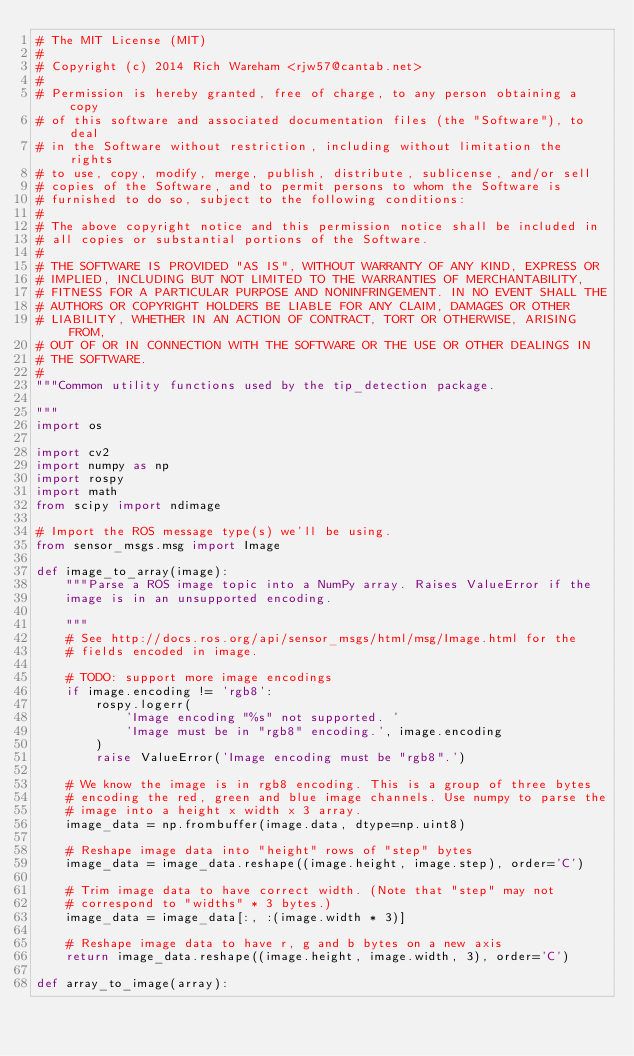Convert code to text. <code><loc_0><loc_0><loc_500><loc_500><_Python_># The MIT License (MIT)
#
# Copyright (c) 2014 Rich Wareham <rjw57@cantab.net>
#
# Permission is hereby granted, free of charge, to any person obtaining a copy
# of this software and associated documentation files (the "Software"), to deal
# in the Software without restriction, including without limitation the rights
# to use, copy, modify, merge, publish, distribute, sublicense, and/or sell
# copies of the Software, and to permit persons to whom the Software is
# furnished to do so, subject to the following conditions:
#
# The above copyright notice and this permission notice shall be included in
# all copies or substantial portions of the Software.
#
# THE SOFTWARE IS PROVIDED "AS IS", WITHOUT WARRANTY OF ANY KIND, EXPRESS OR
# IMPLIED, INCLUDING BUT NOT LIMITED TO THE WARRANTIES OF MERCHANTABILITY,
# FITNESS FOR A PARTICULAR PURPOSE AND NONINFRINGEMENT. IN NO EVENT SHALL THE
# AUTHORS OR COPYRIGHT HOLDERS BE LIABLE FOR ANY CLAIM, DAMAGES OR OTHER
# LIABILITY, WHETHER IN AN ACTION OF CONTRACT, TORT OR OTHERWISE, ARISING FROM,
# OUT OF OR IN CONNECTION WITH THE SOFTWARE OR THE USE OR OTHER DEALINGS IN
# THE SOFTWARE.
#
"""Common utility functions used by the tip_detection package.

"""
import os

import cv2
import numpy as np
import rospy
import math
from scipy import ndimage

# Import the ROS message type(s) we'll be using.
from sensor_msgs.msg import Image

def image_to_array(image):
    """Parse a ROS image topic into a NumPy array. Raises ValueError if the
    image is in an unsupported encoding.

    """
    # See http://docs.ros.org/api/sensor_msgs/html/msg/Image.html for the
    # fields encoded in image.

    # TODO: support more image encodings
    if image.encoding != 'rgb8':
        rospy.logerr(
            'Image encoding "%s" not supported. '
            'Image must be in "rgb8" encoding.', image.encoding
        )
        raise ValueError('Image encoding must be "rgb8".')

    # We know the image is in rgb8 encoding. This is a group of three bytes
    # encoding the red, green and blue image channels. Use numpy to parse the
    # image into a height x width x 3 array.
    image_data = np.frombuffer(image.data, dtype=np.uint8)

    # Reshape image data into "height" rows of "step" bytes
    image_data = image_data.reshape((image.height, image.step), order='C')

    # Trim image data to have correct width. (Note that "step" may not
    # correspond to "widths" * 3 bytes.)
    image_data = image_data[:, :(image.width * 3)]

    # Reshape image data to have r, g and b bytes on a new axis
    return image_data.reshape((image.height, image.width, 3), order='C')

def array_to_image(array):</code> 